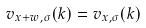Convert formula to latex. <formula><loc_0><loc_0><loc_500><loc_500>v _ { x + w , \sigma } ( k ) = v _ { x , \sigma } ( k )</formula> 